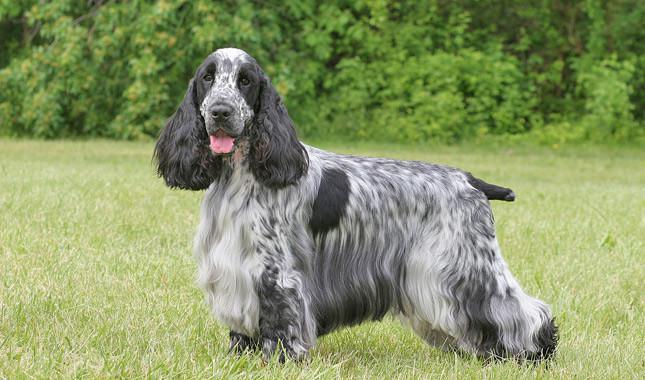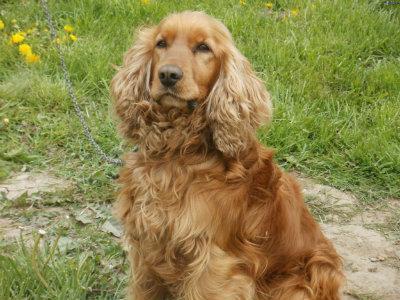The first image is the image on the left, the second image is the image on the right. Examine the images to the left and right. Is the description "At least one half of the dogs have their mouths open." accurate? Answer yes or no. Yes. 